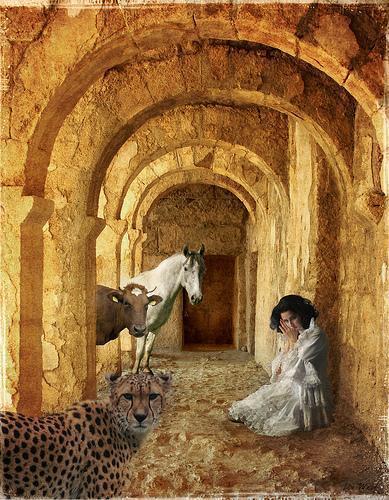How many people are there?
Give a very brief answer. 1. 